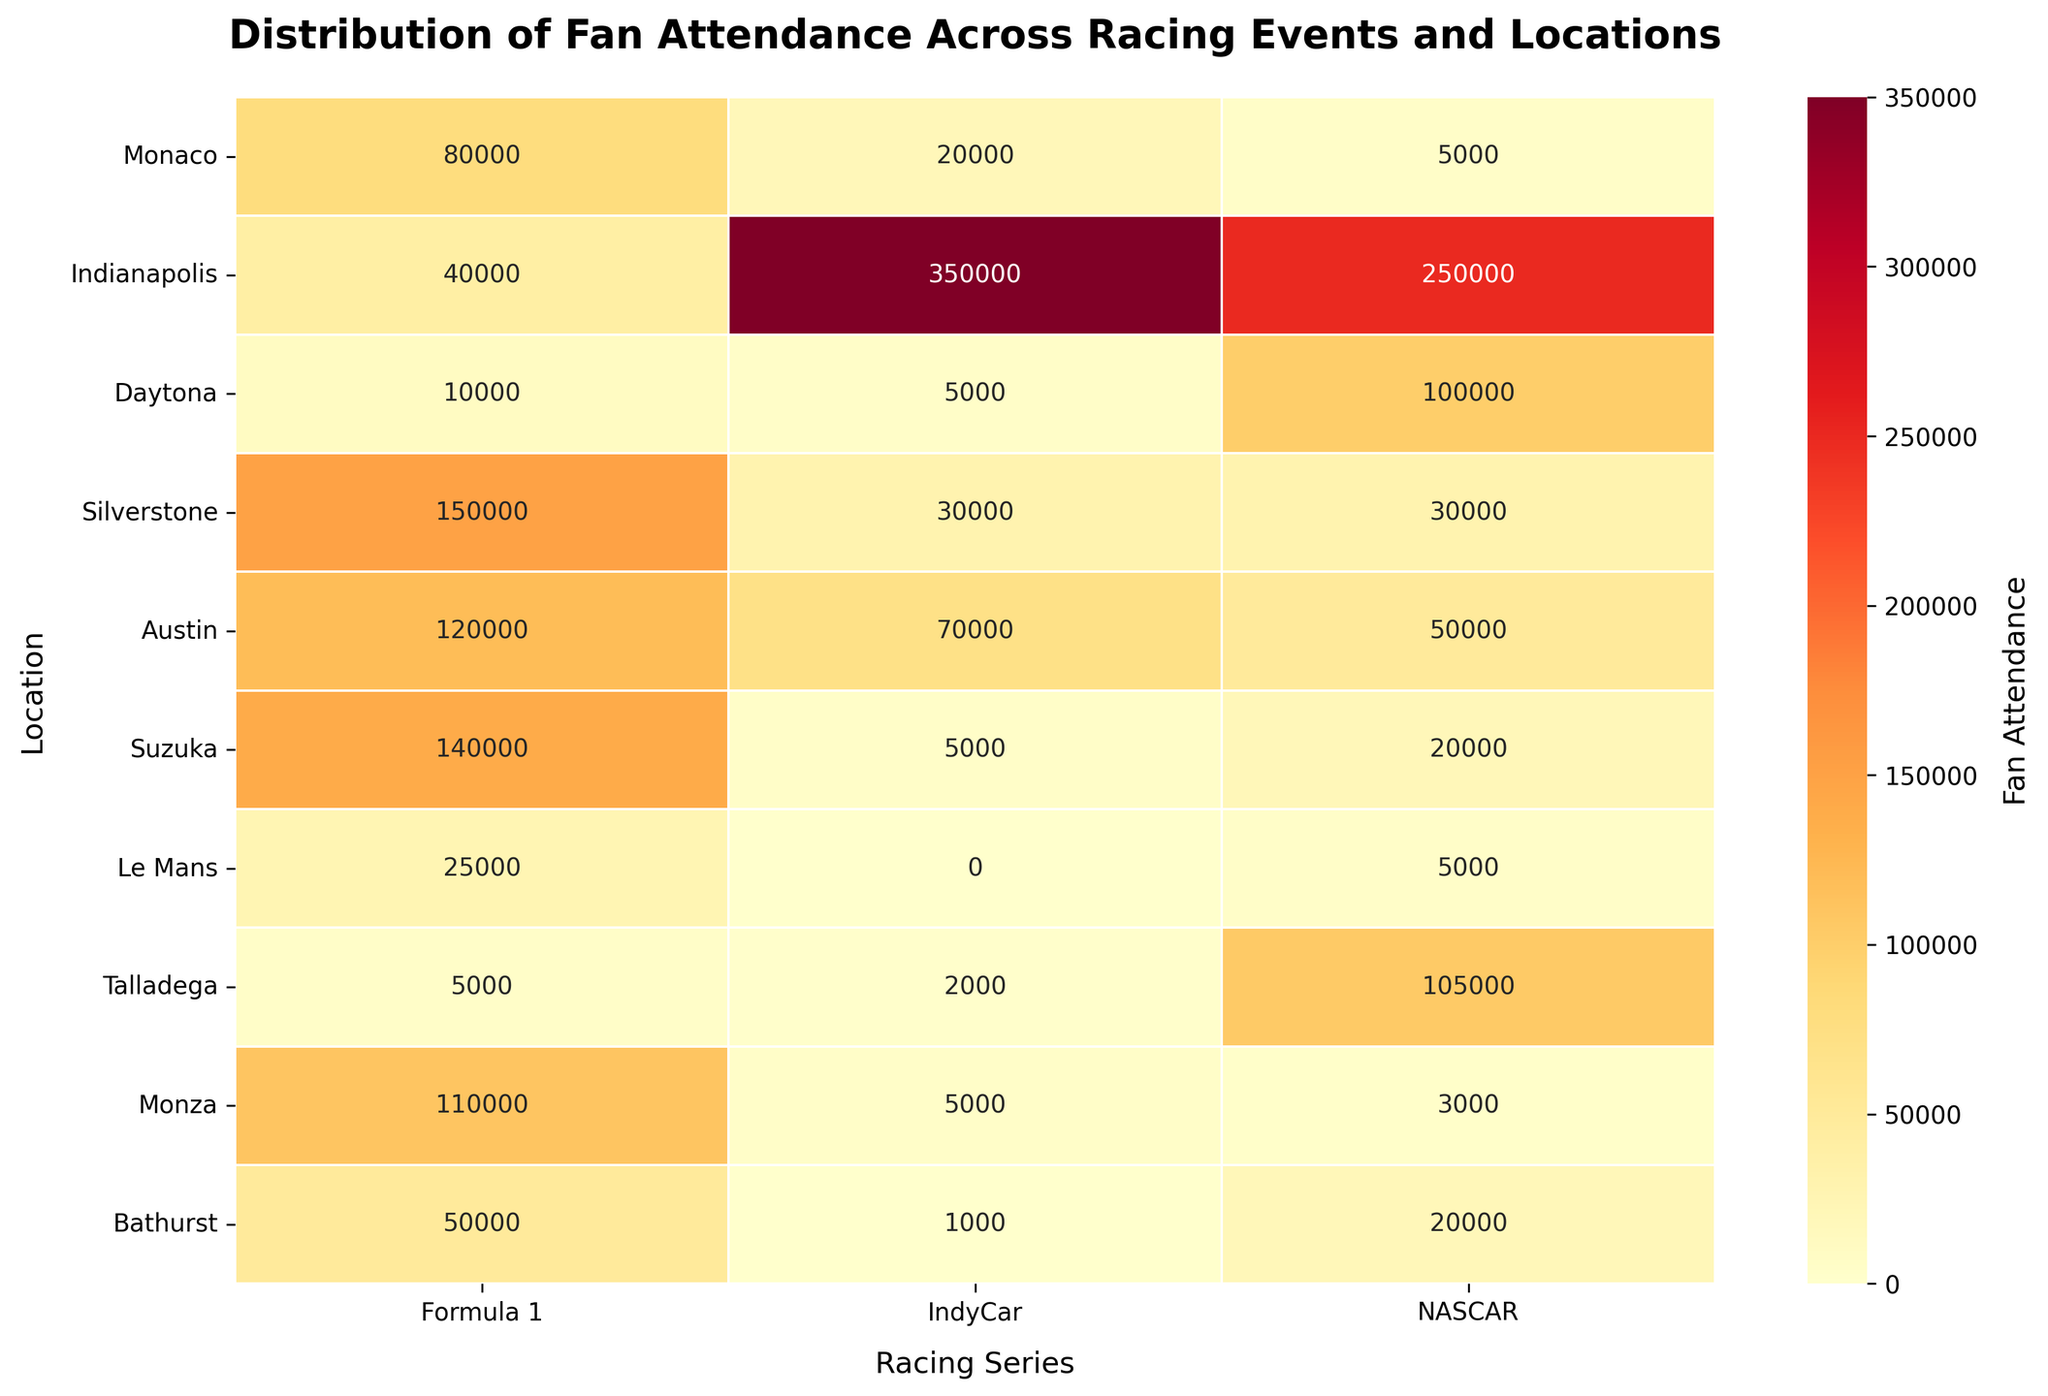what's the highest fan attendance for Formula 1 events? Look for the highest numeric value in the 'Formula 1' column. The highest value is 150,000 at Silverstone.
Answer: 150,000 Which location has the lowest fan attendance for NASCAR? Check the 'NASCAR' column for the smallest value. The lowest attendance is 3,000 at Monza.
Answer: Monza What is the sum of fan attendance for all events in Suzuka? Add the attendance numbers for all events in Suzuka. Formula 1 (140,000) + IndyCar (5,000) + NASCAR (20,000) = 165,000.
Answer: 165,000 How does the fan attendance for Daytona's NASCAR event compare to Indianapolis's NASCAR event? Compare the values in the 'NASCAR' column for Daytona (100,000) and Indianapolis (250,000). Indianapolis has 150,000 more.
Answer: Indianapolis has more Which racing series has the most fan attendance in Monaco, and what is that number? Compare the values in the row for Monaco. Formula 1 (80,000) has the highest attendance.
Answer: Formula 1, 80,000 Is there any location where IndyCar attendance surpasses Formula 1 attendance? Compare values row-by-row for IndyCar and Formula 1 columns. Indianapolis (IndyCar 350,000 vs Formula 1 40,000) is the only location where this is true.
Answer: Indianapolis For which racing series do Bathurst and Talladega have the highest attendance compared to the other series hosted at these venues? Compare fan attendance across the three series for Bathurst and Talladega. Bathurst has the highest for Formula 1 (50,000) and Talladega has the highest for NASCAR (105,000).
Answer: Bathurst: Formula 1, Talladega: NASCAR What's the difference in total fan attendance for all series between Austin and Le Mans? Sum the total attendance for all series in Austin and Le Mans, then find the difference. Austin (120,000 + 70,000 + 50,000 = 240,000), Le Mans (25,000 + 0 + 5,000 = 30,000). The difference is 210,000.
Answer: 210,000 